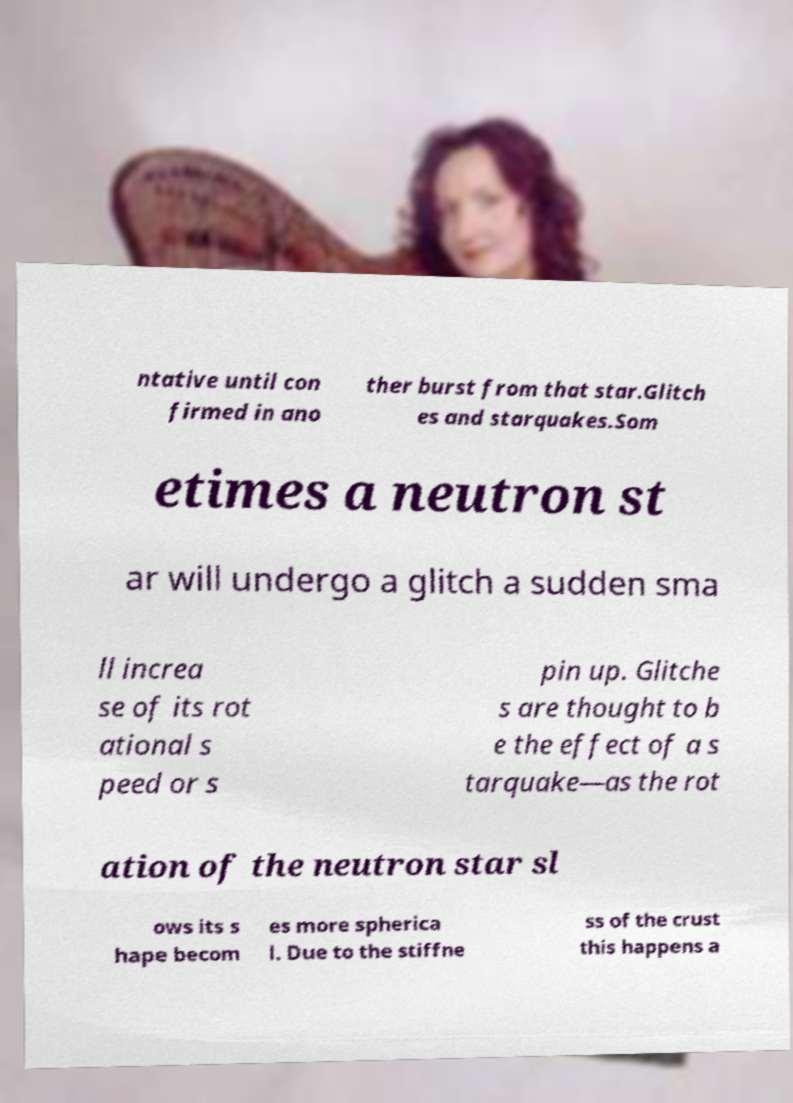Can you accurately transcribe the text from the provided image for me? ntative until con firmed in ano ther burst from that star.Glitch es and starquakes.Som etimes a neutron st ar will undergo a glitch a sudden sma ll increa se of its rot ational s peed or s pin up. Glitche s are thought to b e the effect of a s tarquake—as the rot ation of the neutron star sl ows its s hape becom es more spherica l. Due to the stiffne ss of the crust this happens a 